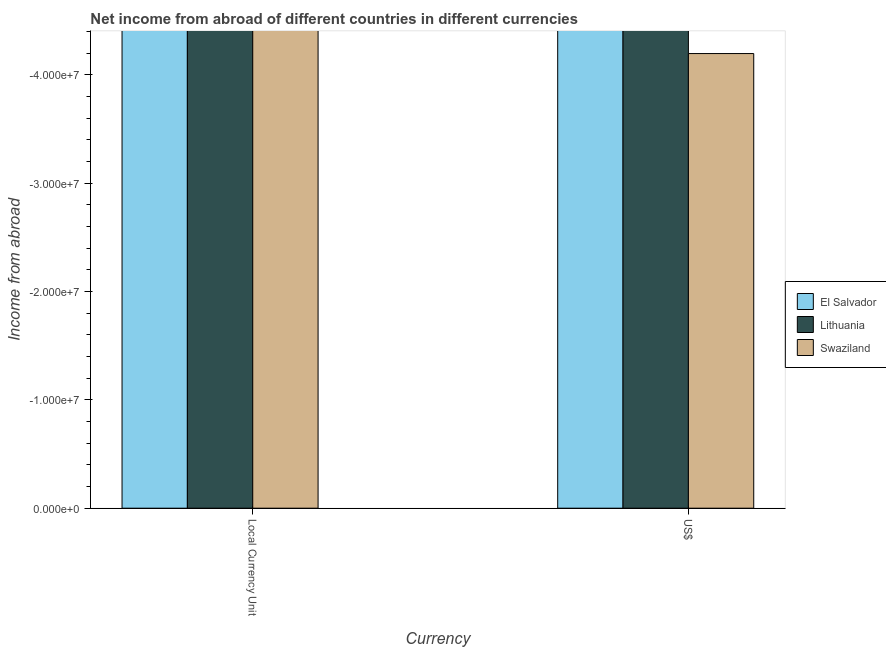Are the number of bars per tick equal to the number of legend labels?
Your response must be concise. No. Are the number of bars on each tick of the X-axis equal?
Provide a succinct answer. Yes. What is the label of the 1st group of bars from the left?
Ensure brevity in your answer.  Local Currency Unit. What is the income from abroad in constant 2005 us$ in Lithuania?
Offer a terse response. 0. Across all countries, what is the minimum income from abroad in constant 2005 us$?
Your answer should be compact. 0. What is the difference between the income from abroad in constant 2005 us$ in El Salvador and the income from abroad in us$ in Swaziland?
Offer a terse response. 0. In how many countries, is the income from abroad in us$ greater than -36000000 units?
Your answer should be compact. 0. In how many countries, is the income from abroad in us$ greater than the average income from abroad in us$ taken over all countries?
Your response must be concise. 0. How many bars are there?
Your answer should be very brief. 0. How many countries are there in the graph?
Ensure brevity in your answer.  3. What is the difference between two consecutive major ticks on the Y-axis?
Provide a short and direct response. 1.00e+07. Where does the legend appear in the graph?
Your answer should be compact. Center right. How many legend labels are there?
Your answer should be compact. 3. What is the title of the graph?
Offer a terse response. Net income from abroad of different countries in different currencies. Does "Maldives" appear as one of the legend labels in the graph?
Give a very brief answer. No. What is the label or title of the X-axis?
Ensure brevity in your answer.  Currency. What is the label or title of the Y-axis?
Provide a succinct answer. Income from abroad. What is the Income from abroad of Lithuania in Local Currency Unit?
Ensure brevity in your answer.  0. What is the Income from abroad of El Salvador in US$?
Offer a very short reply. 0. What is the Income from abroad of Lithuania in US$?
Your answer should be compact. 0. What is the Income from abroad in Swaziland in US$?
Your response must be concise. 0. What is the total Income from abroad of El Salvador in the graph?
Ensure brevity in your answer.  0. What is the total Income from abroad of Lithuania in the graph?
Make the answer very short. 0. What is the total Income from abroad in Swaziland in the graph?
Ensure brevity in your answer.  0. 